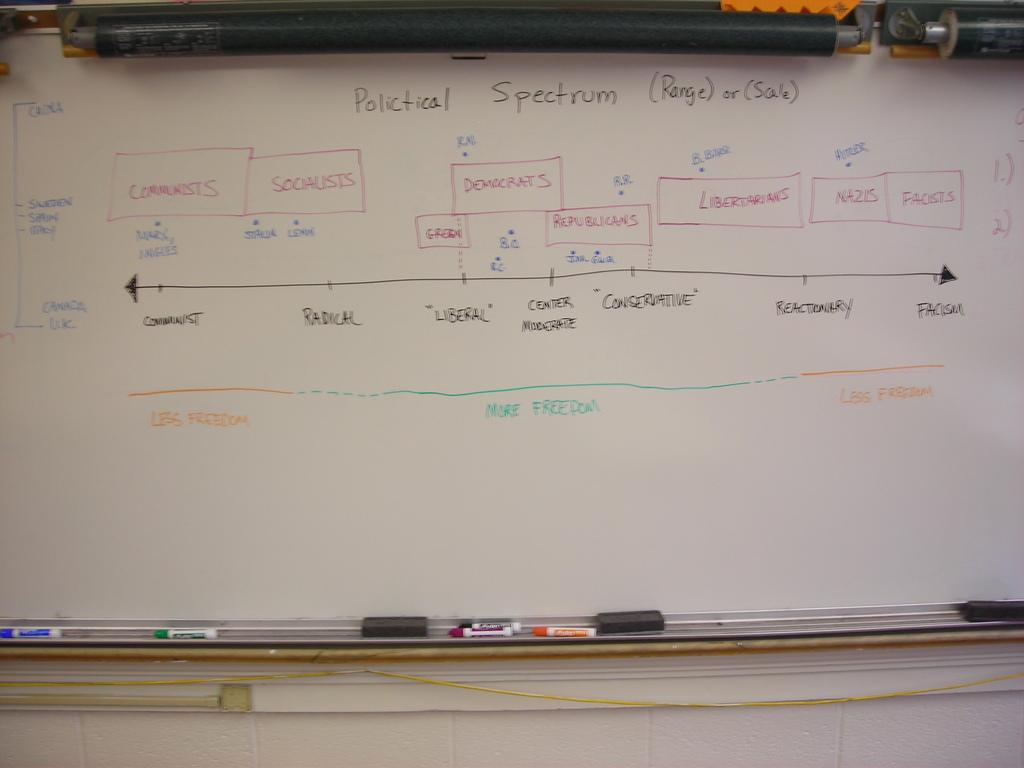<image>
Render a clear and concise summary of the photo. Words on a board that say "Political Spectrum" on top. 